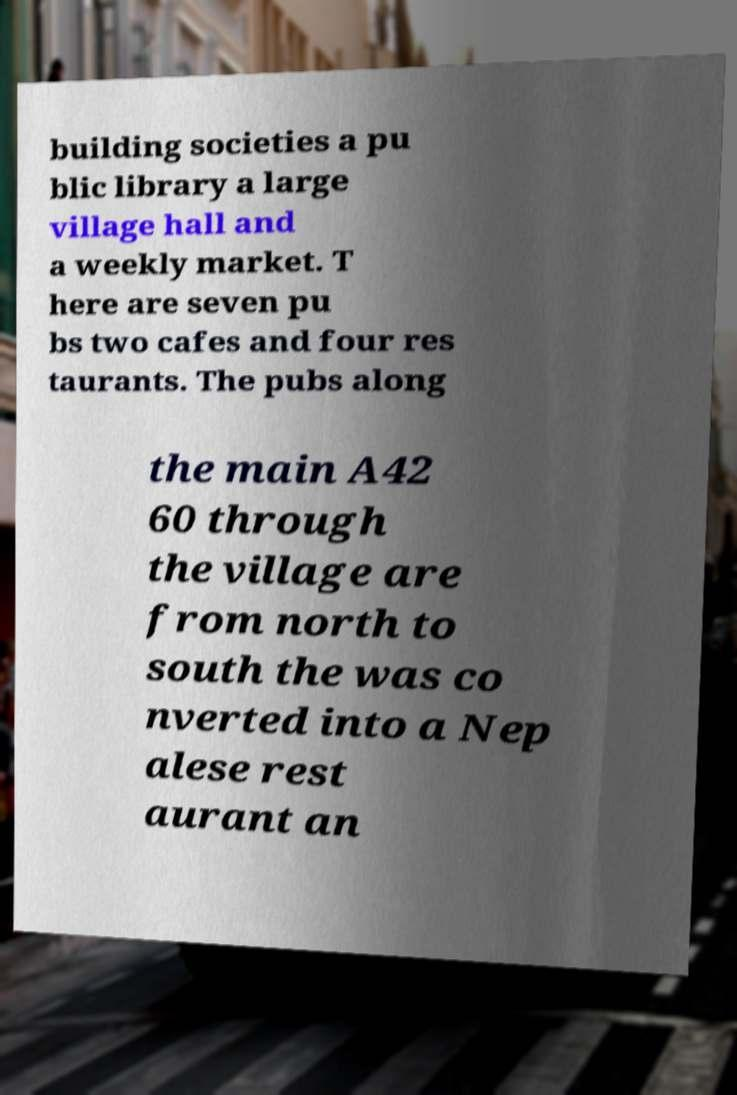Could you extract and type out the text from this image? building societies a pu blic library a large village hall and a weekly market. T here are seven pu bs two cafes and four res taurants. The pubs along the main A42 60 through the village are from north to south the was co nverted into a Nep alese rest aurant an 